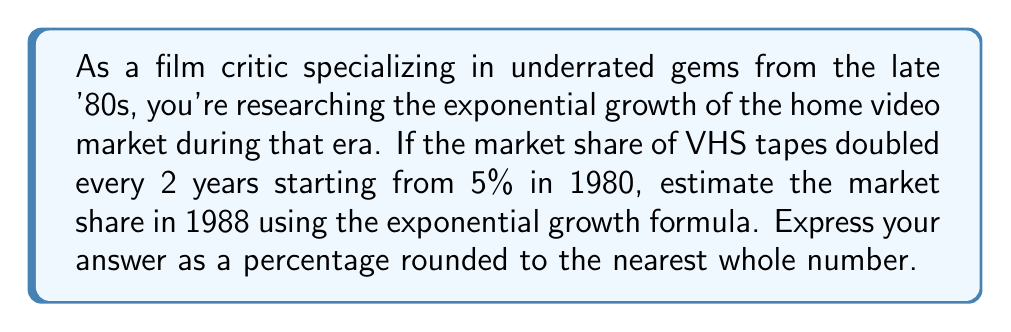Provide a solution to this math problem. Let's approach this step-by-step:

1) The exponential growth formula is:
   $$A = P(1 + r)^t$$
   where A is the final amount, P is the initial amount, r is the growth rate, and t is the time period.

2) In this case:
   P = 5% (initial market share in 1980)
   r = 100% = 1 (doubles every 2 years, so 100% growth rate)
   t = 4 (from 1980 to 1988 is 8 years, but we double every 2 years, so t = 8/2 = 4)

3) Plugging these values into the formula:
   $$A = 5(1 + 1)^4$$

4) Simplify:
   $$A = 5(2)^4$$

5) Calculate:
   $$A = 5 * 16 = 80$$

6) Therefore, the market share in 1988 would be 80%.

This exponential growth mirrors the rapid expansion of the home video market in the late '80s, which saw many underrated films finding new audiences through VHS rentals and sales.
Answer: 80% 